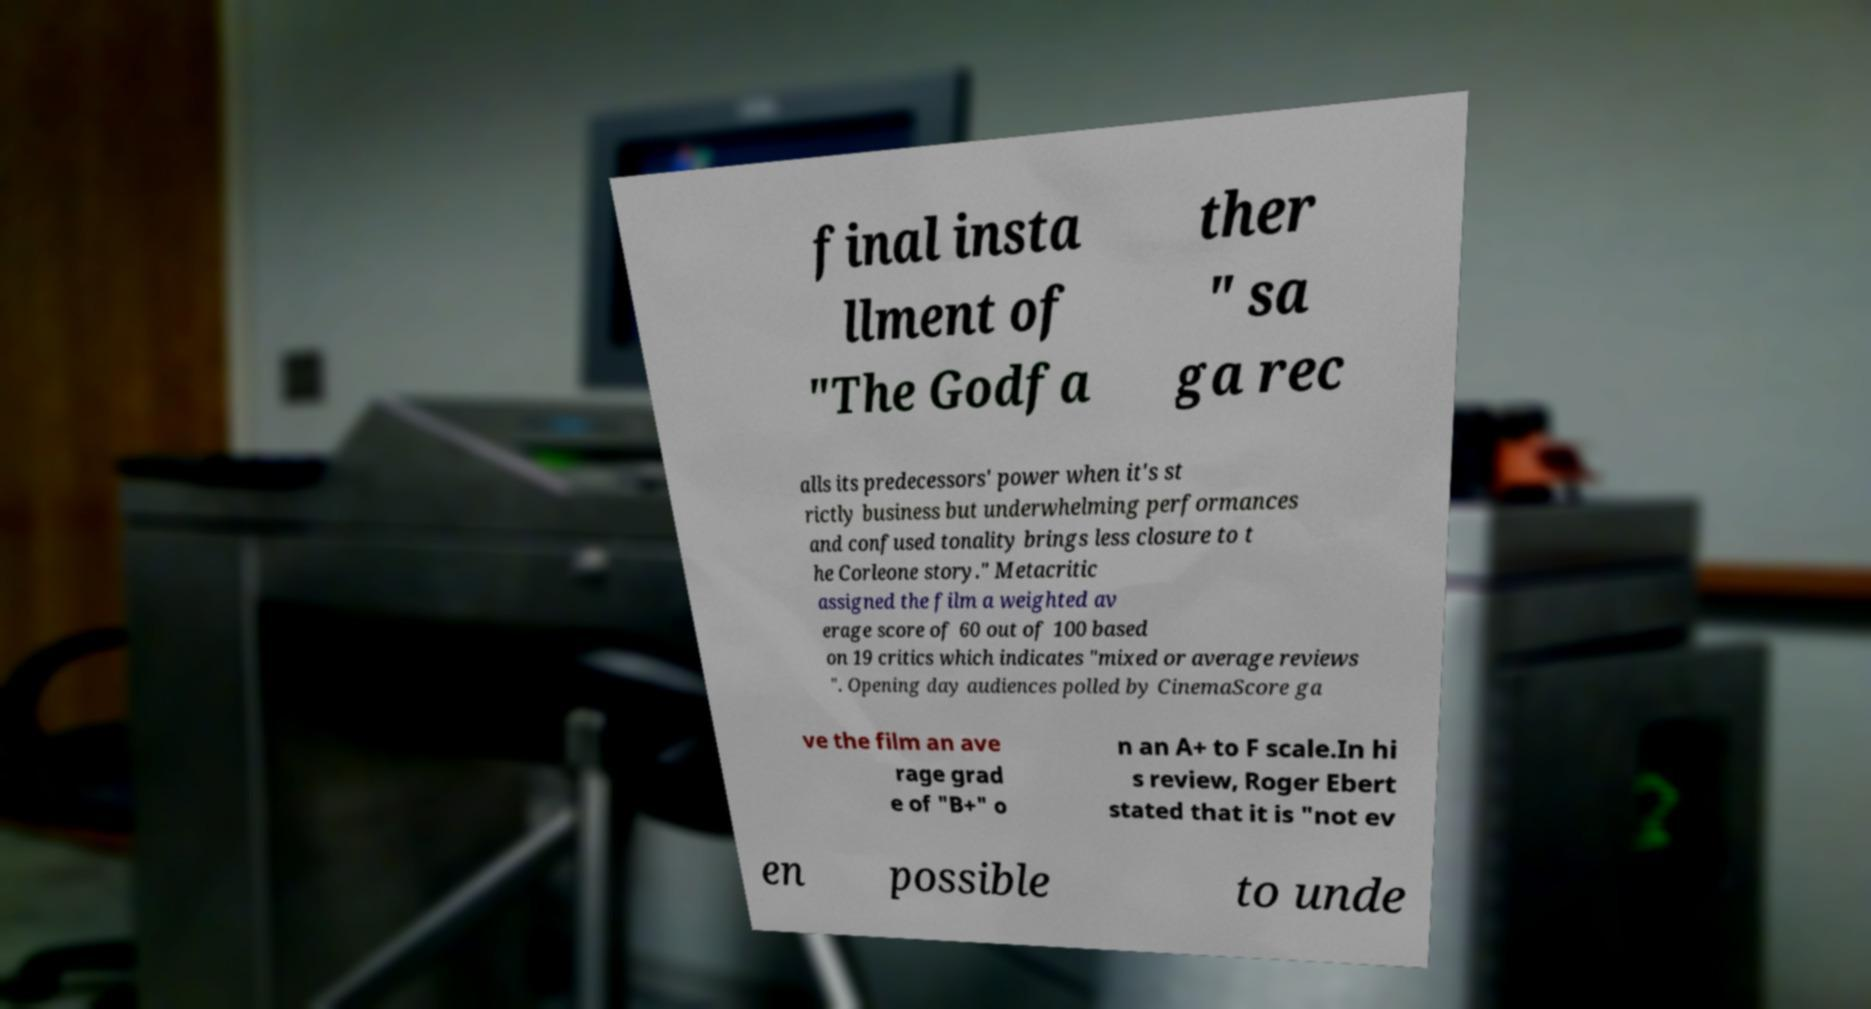Please read and relay the text visible in this image. What does it say? final insta llment of "The Godfa ther " sa ga rec alls its predecessors' power when it's st rictly business but underwhelming performances and confused tonality brings less closure to t he Corleone story." Metacritic assigned the film a weighted av erage score of 60 out of 100 based on 19 critics which indicates "mixed or average reviews ". Opening day audiences polled by CinemaScore ga ve the film an ave rage grad e of "B+" o n an A+ to F scale.In hi s review, Roger Ebert stated that it is "not ev en possible to unde 